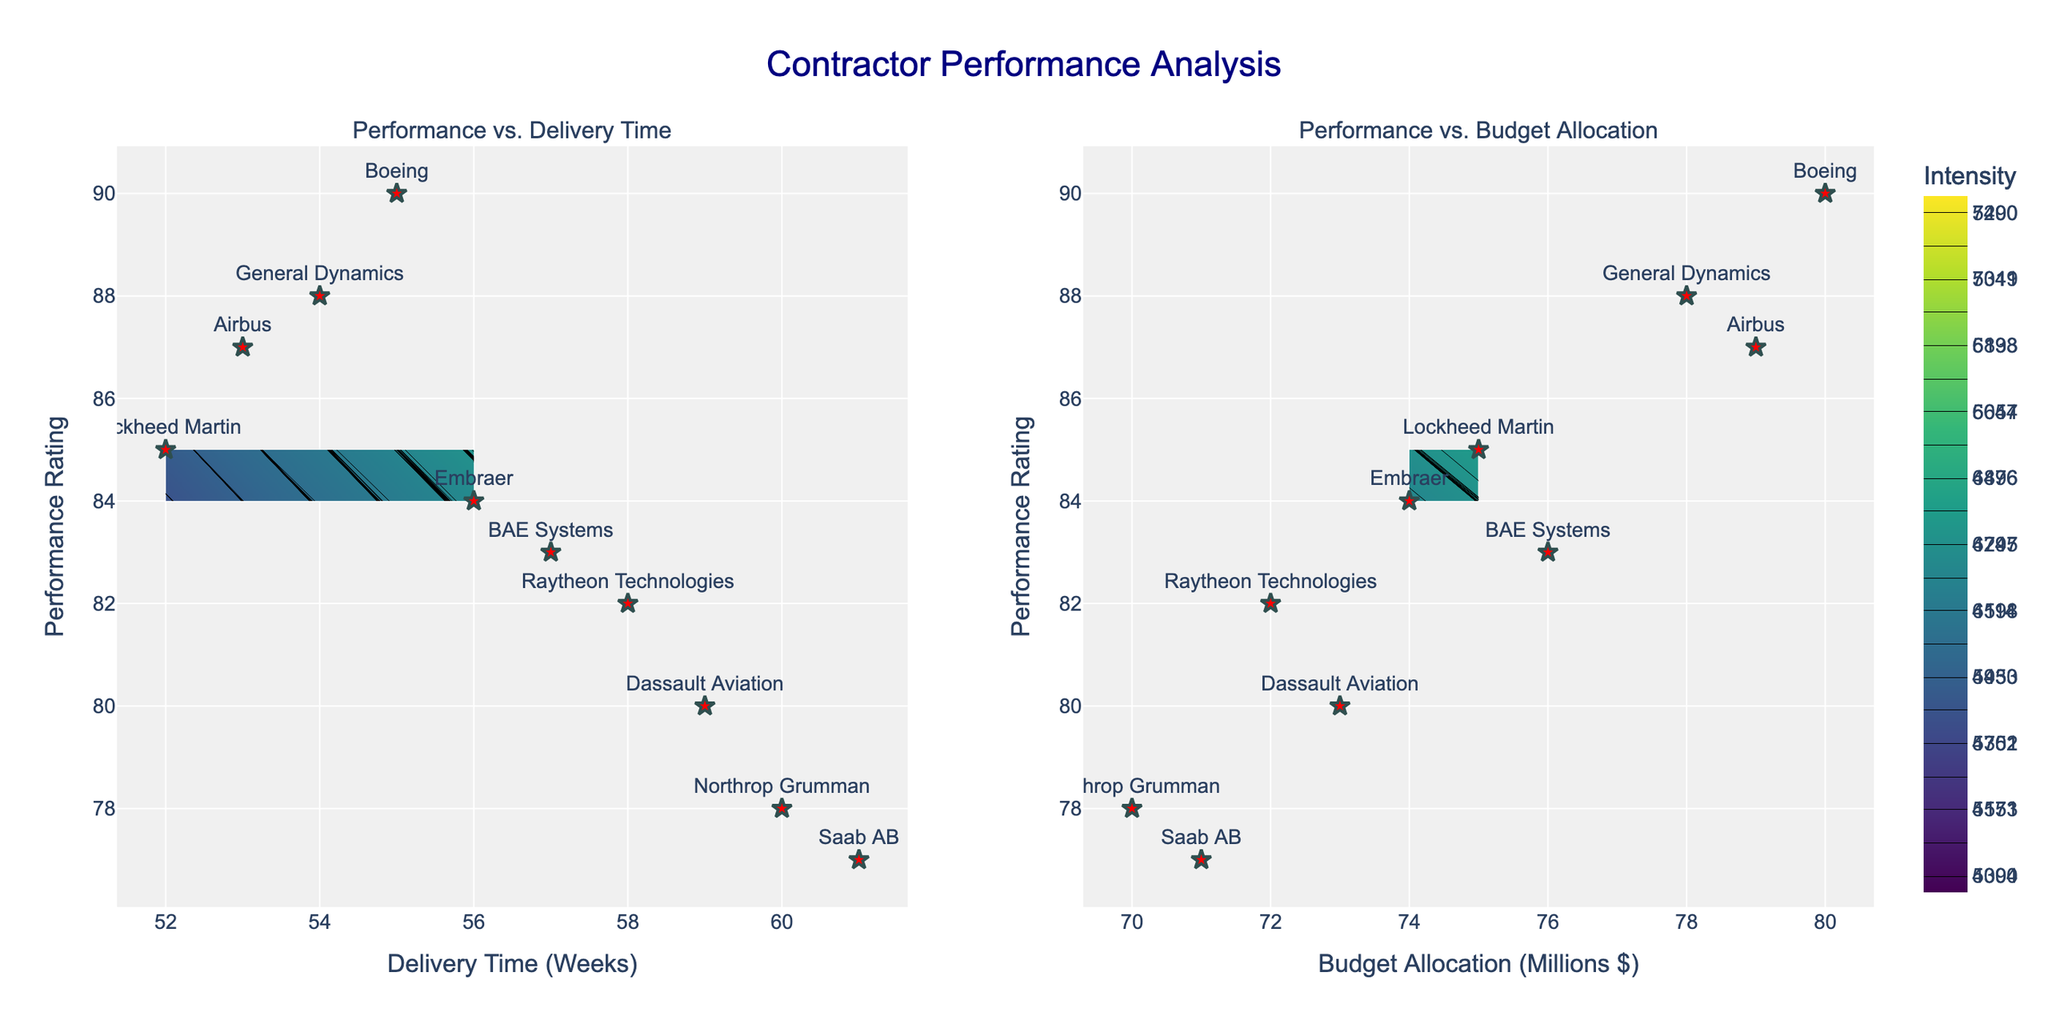What's the title of the figure? The title of the figure is displayed at the top and reads "Contractor Performance Analysis".
Answer: Contractor Performance Analysis What are the labels for the x-axes in both subplots? The label for the x-axis in the first subplot is "Delivery Time (Weeks)", and in the second subplot is "Budget Allocation (Millions $)".
Answer: Delivery Time (Weeks), Budget Allocation (Millions $) How many contractors are shown in the plots? The data points are labeled with the contractors' names. Counting these labeled points reveals there are 10 contractors.
Answer: 10 Which contractor has the highest performance rating and what is that rating? The highest performance rating can be seen where the scatter plot markers appear at the top of the y-axis. Boeing has the highest rating of 90.
Answer: Boeing, 90 Which contour plot has a wider range of x-values? By observing the x-axes of both subplots, the "Budget Allocation (Millions $)" subplot has a range from 70 to 80, whereas "Delivery Time (Weeks)" ranges from 52 to 61.
Answer: Delivery Time (Weeks) How does a higher budget allocation affect the performance rating intensity, based on the second subplot? Higher budget allocation tends to increase the performance rating intensity, as indicated by the color gradient moving from lighter to darker shades towards the higher budget allocations.
Answer: Increases intensity Which contractor has the closest delivery time to the average delivery time shown in the first subplot? The average delivery time can be roughly estimated by adding all delivery times (52 + 55 + 60 + 58 + 54 + 57 + 53 + 59 + 61 + 56 = 565) and dividing by the number of contractors (10), giving an average of 56.5 weeks. Embraer, at 56 weeks, is closest to this average.
Answer: Embraer How does the performance rating compare between contractors with delivery times at the extreme ends of the range (52 and 61 weeks)? Lockheed Martin has a performance rating of 85 at 52 weeks, while Saab AB has a rating of 77 at 61 weeks, showing a lower performance rating for longer delivery time.
Answer: Lower at 61 weeks Which subplot shows the highest intensity of the performance rating, and what range of x-values does it correspond to? The intensity is highest in the first subplot ("Performance vs. Delivery Time") around the lower end of the delivery time range, roughly between 52 to 55 weeks.
Answer: First subplot, 52 to 55 weeks 